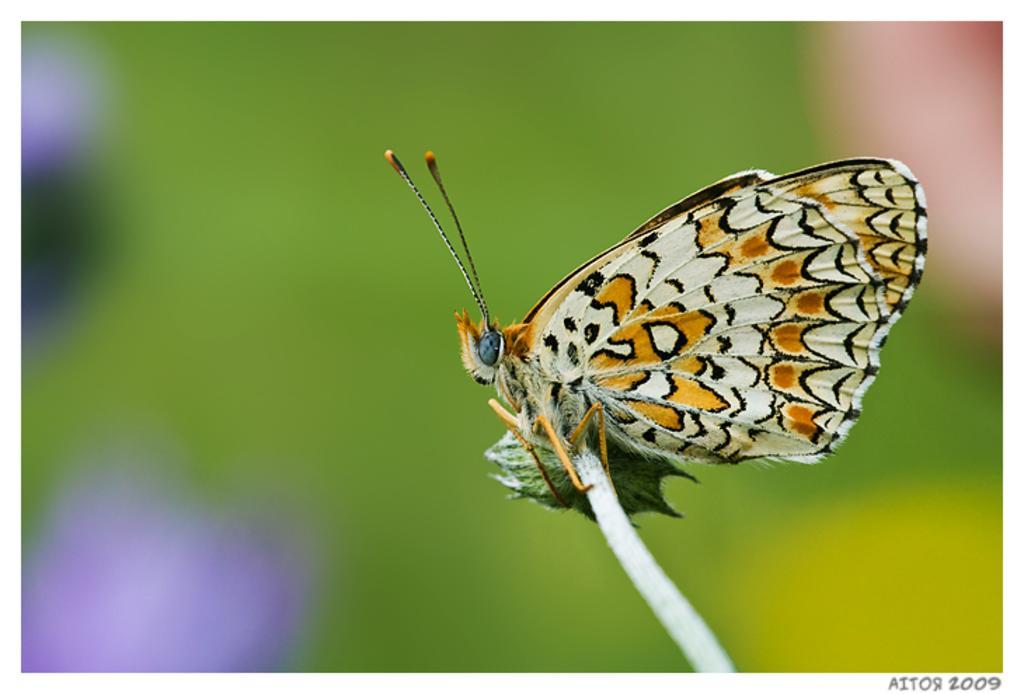Can you describe this image briefly? In this image there is a butterfly on a stick. The background is blurry. 